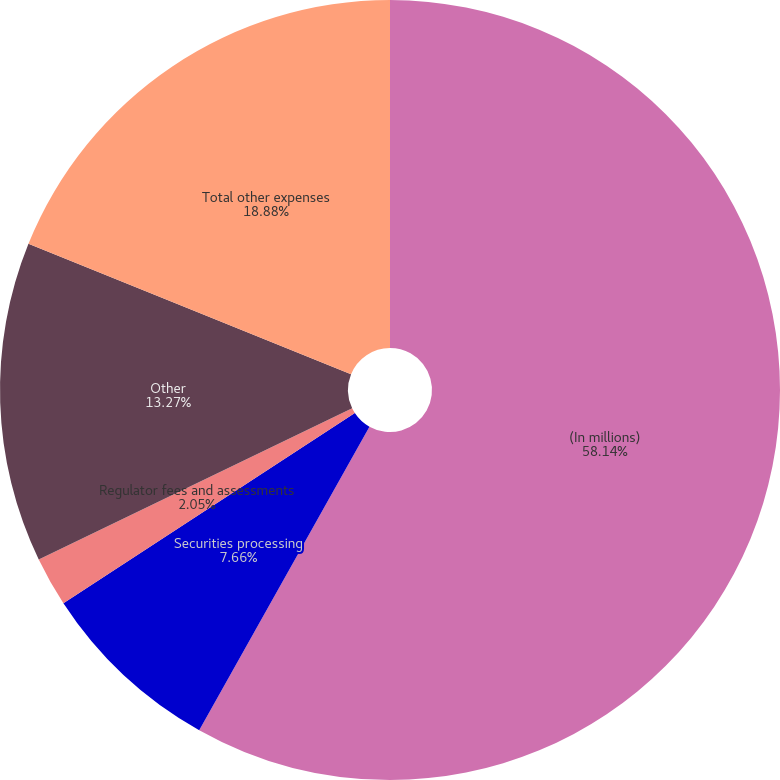Convert chart. <chart><loc_0><loc_0><loc_500><loc_500><pie_chart><fcel>(In millions)<fcel>Securities processing<fcel>Regulator fees and assessments<fcel>Other<fcel>Total other expenses<nl><fcel>58.13%<fcel>7.66%<fcel>2.05%<fcel>13.27%<fcel>18.88%<nl></chart> 